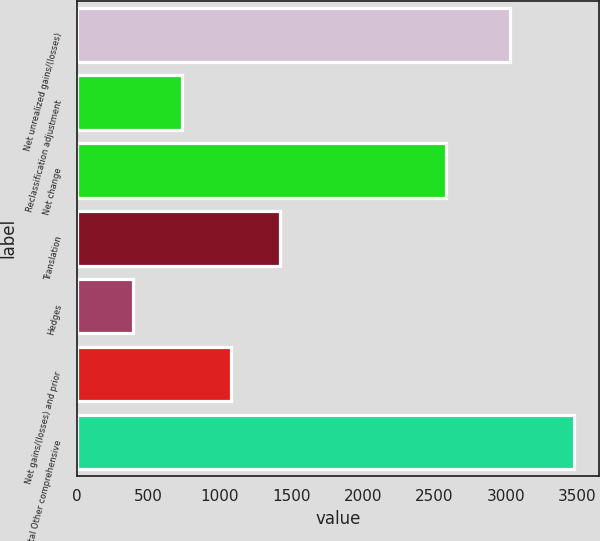Convert chart. <chart><loc_0><loc_0><loc_500><loc_500><bar_chart><fcel>Net unrealized gains/(losses)<fcel>Reclassification adjustment<fcel>Net change<fcel>Translation<fcel>Hedges<fcel>Net gains/(losses) and prior<fcel>Total Other comprehensive<nl><fcel>3029<fcel>733.6<fcel>2585<fcel>1419.2<fcel>390.8<fcel>1076.4<fcel>3476<nl></chart> 